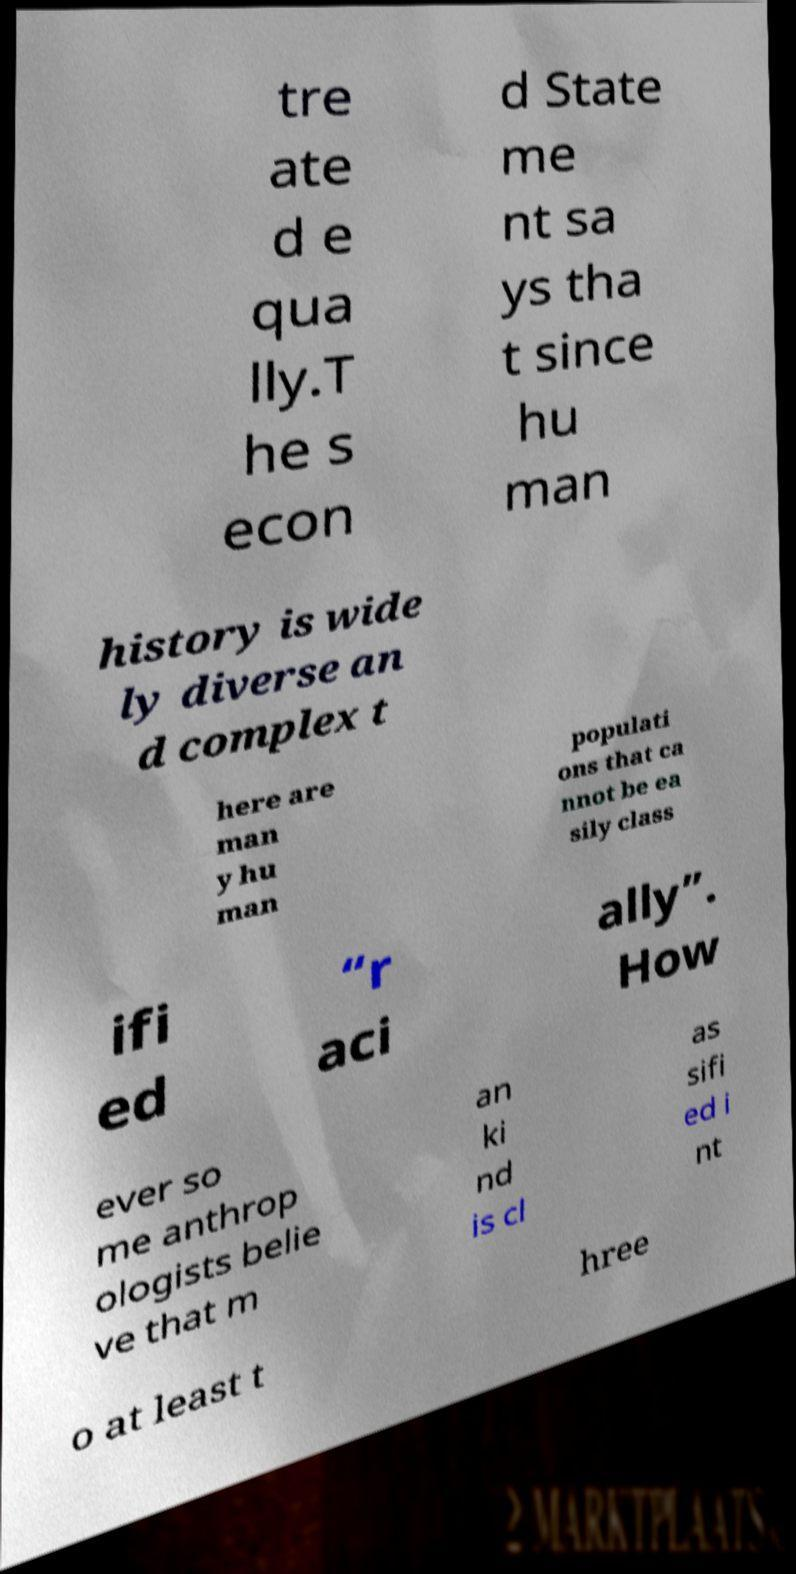For documentation purposes, I need the text within this image transcribed. Could you provide that? tre ate d e qua lly.T he s econ d State me nt sa ys tha t since hu man history is wide ly diverse an d complex t here are man y hu man populati ons that ca nnot be ea sily class ifi ed “r aci ally”. How ever so me anthrop ologists belie ve that m an ki nd is cl as sifi ed i nt o at least t hree 